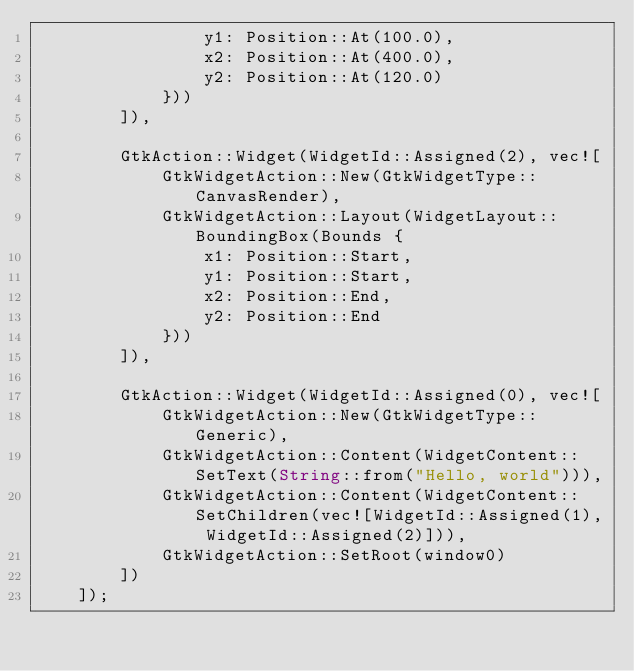Convert code to text. <code><loc_0><loc_0><loc_500><loc_500><_Rust_>                y1: Position::At(100.0),
                x2: Position::At(400.0),
                y2: Position::At(120.0)
            }))
        ]),

        GtkAction::Widget(WidgetId::Assigned(2), vec![
            GtkWidgetAction::New(GtkWidgetType::CanvasRender),
            GtkWidgetAction::Layout(WidgetLayout::BoundingBox(Bounds {
                x1: Position::Start,
                y1: Position::Start,
                x2: Position::End,
                y2: Position::End
            }))
        ]),

        GtkAction::Widget(WidgetId::Assigned(0), vec![
            GtkWidgetAction::New(GtkWidgetType::Generic),
            GtkWidgetAction::Content(WidgetContent::SetText(String::from("Hello, world"))),
            GtkWidgetAction::Content(WidgetContent::SetChildren(vec![WidgetId::Assigned(1), WidgetId::Assigned(2)])),
            GtkWidgetAction::SetRoot(window0)
        ])
    ]);
</code> 